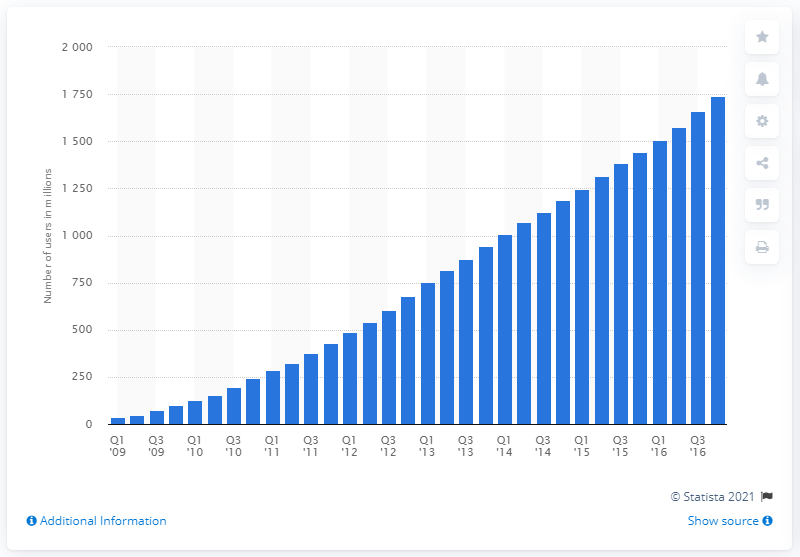Highlight a few significant elements in this photo. As of the fourth quarter of 2016, Facebook had 17,400 mobile monthly active users. In the first quarter of 2014, Facebook surpassed 1740 mobile MAU. 